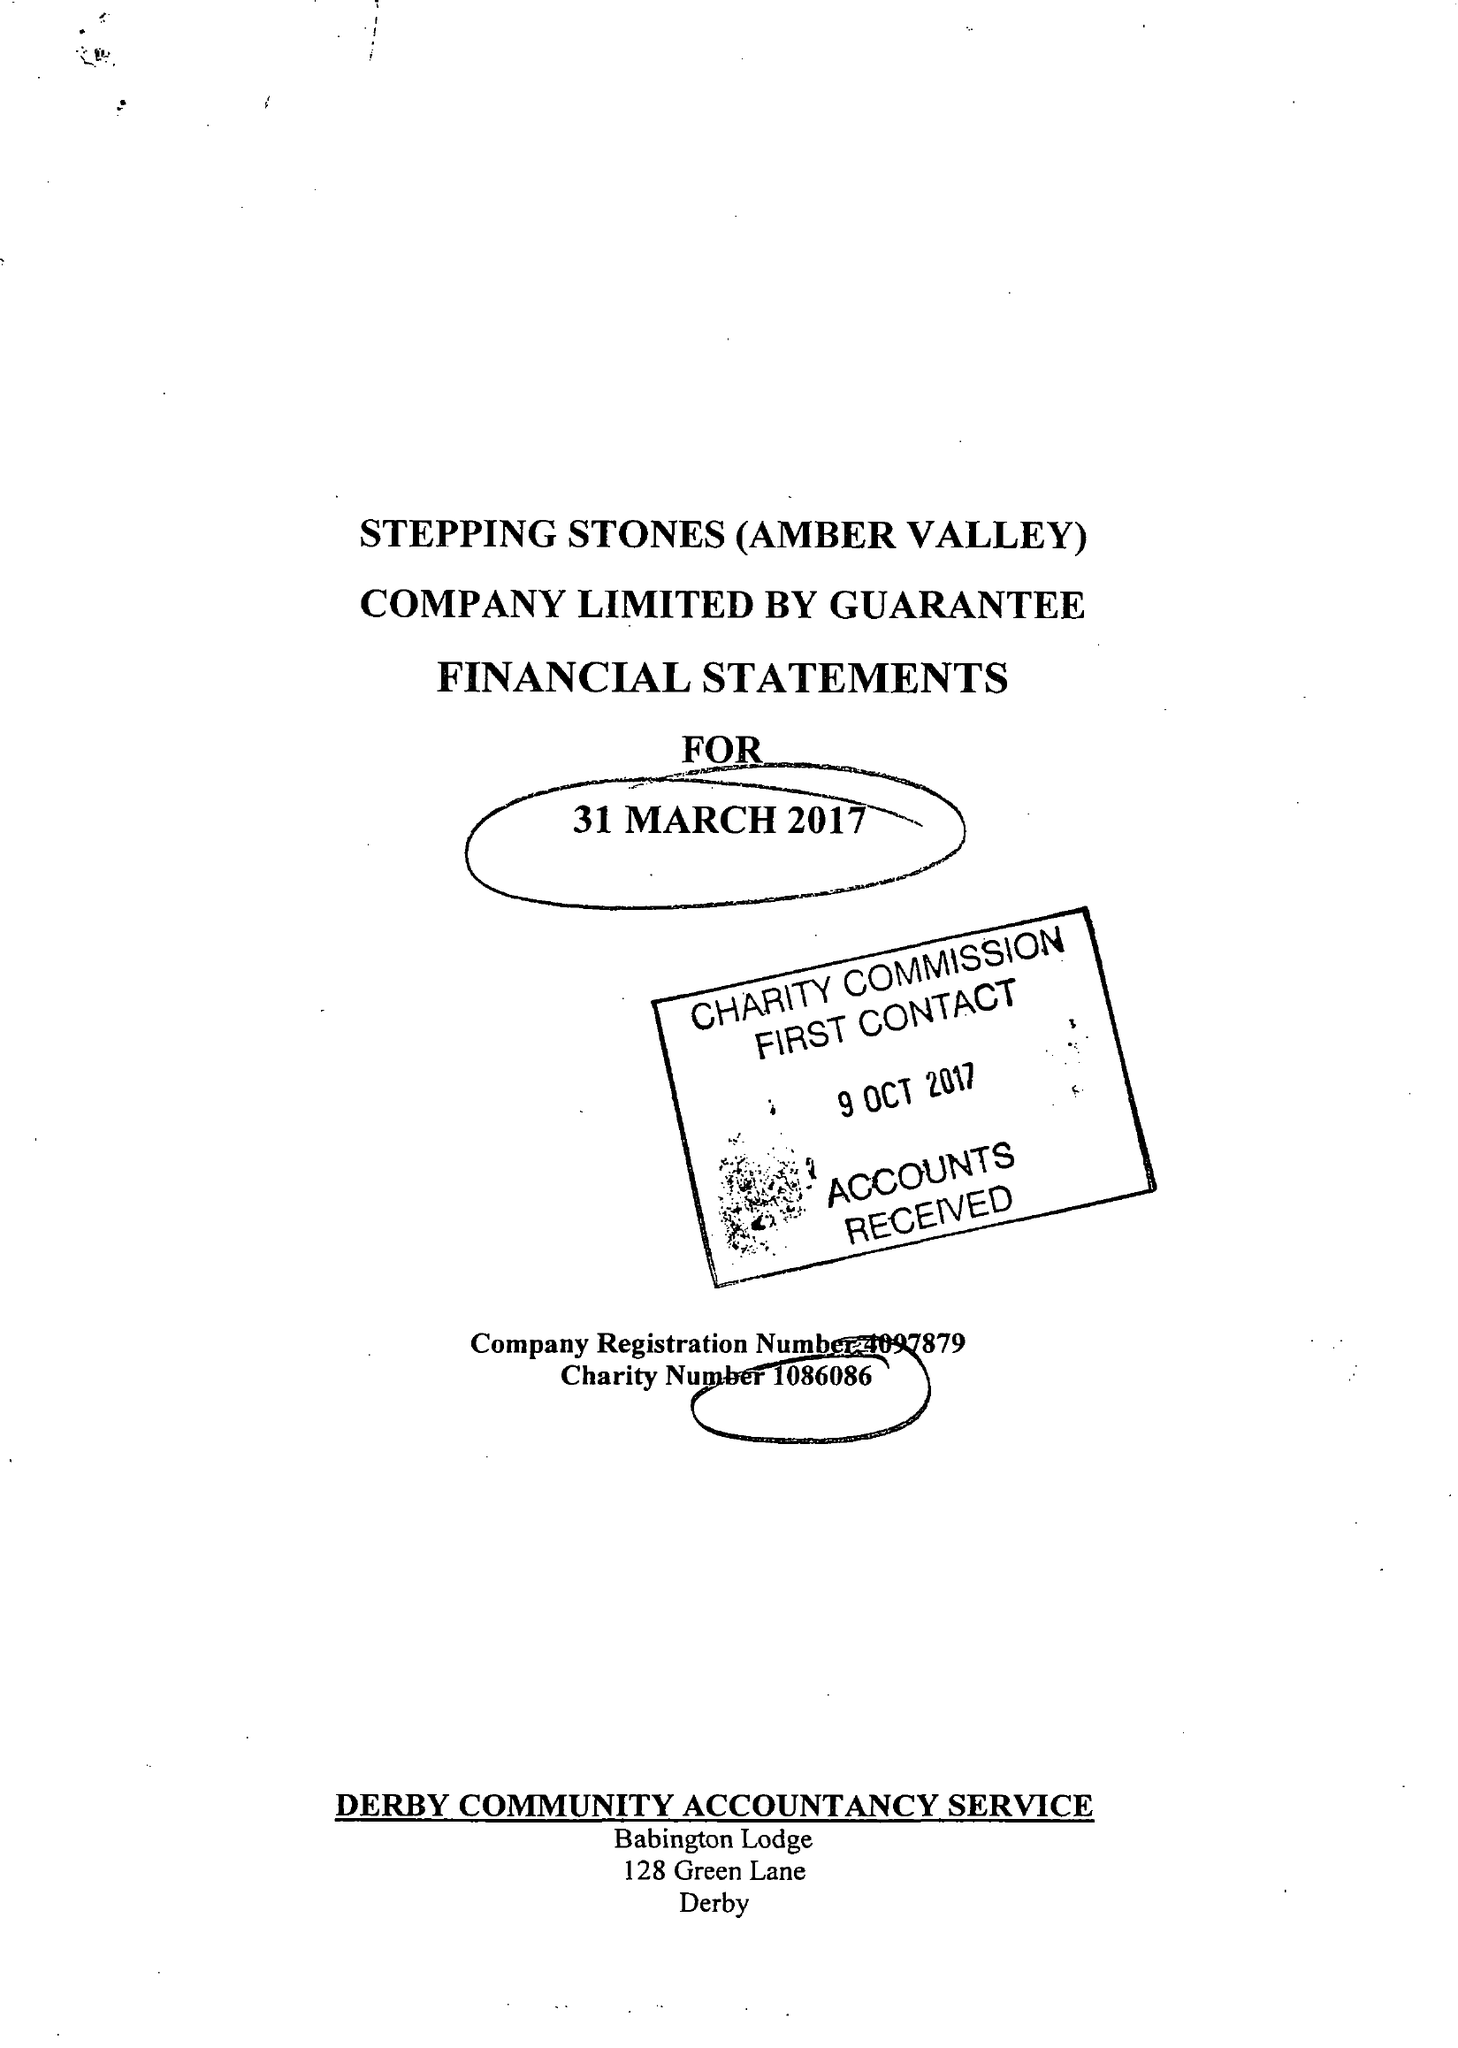What is the value for the address__street_line?
Answer the question using a single word or phrase. 210 NOTTINGHAM ROAD 